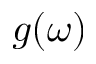Convert formula to latex. <formula><loc_0><loc_0><loc_500><loc_500>g ( \omega )</formula> 